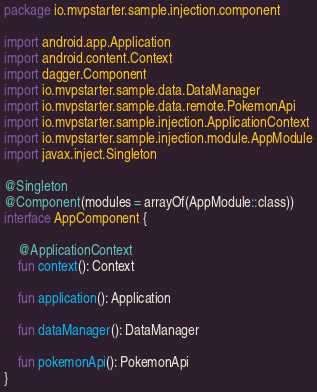Convert code to text. <code><loc_0><loc_0><loc_500><loc_500><_Kotlin_>package io.mvpstarter.sample.injection.component

import android.app.Application
import android.content.Context
import dagger.Component
import io.mvpstarter.sample.data.DataManager
import io.mvpstarter.sample.data.remote.PokemonApi
import io.mvpstarter.sample.injection.ApplicationContext
import io.mvpstarter.sample.injection.module.AppModule
import javax.inject.Singleton

@Singleton
@Component(modules = arrayOf(AppModule::class))
interface AppComponent {

    @ApplicationContext
    fun context(): Context

    fun application(): Application

    fun dataManager(): DataManager

    fun pokemonApi(): PokemonApi
}
</code> 